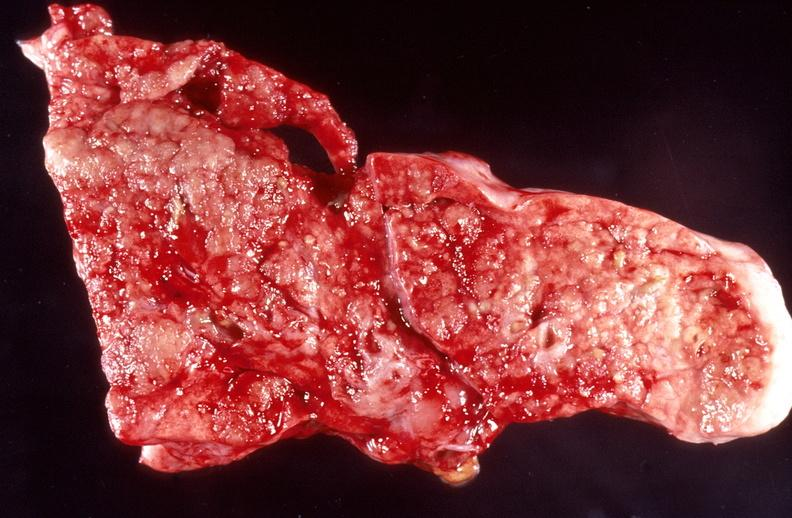what does this image show?
Answer the question using a single word or phrase. Lung 